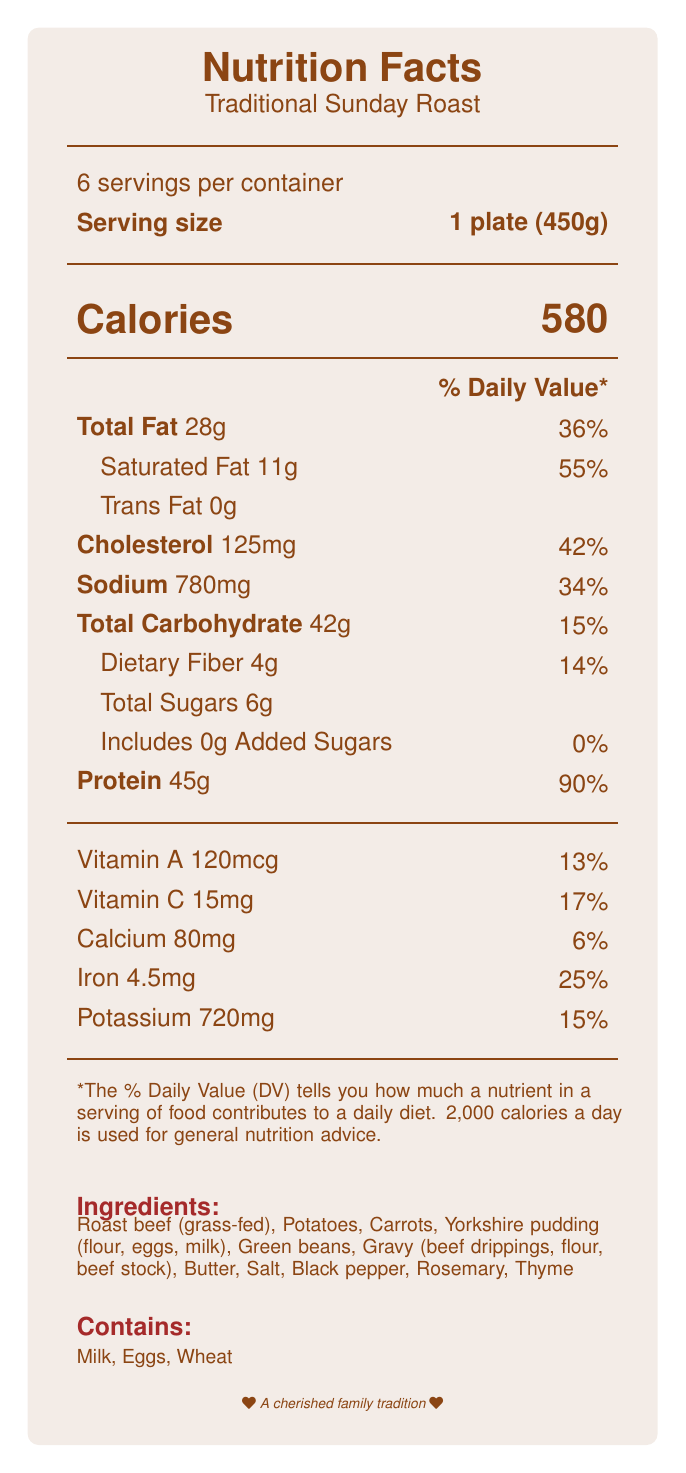What is the serving size of the Sunday roast dinner? The serving size is explicitly mentioned as "1 plate (450g)" in the document.
Answer: 1 plate (450g) How many servings are there in the entire container? The document specifies there are 6 servings per container.
Answer: 6 How many calories are in one serving of the Sunday roast dinner? The document states that one serving has 580 calories.
Answer: 580 What percentage of the Daily Value is the total fat content? The document mentions that the total fat of 28g corresponds to 36% of the Daily Value.
Answer: 36% How much protein is in one serving of the dish? The protein content per serving is listed as 45g in the document.
Answer: 45g Which ingredients contain common allergens? A. Roast beef, Potatoes, Carrots B. Milk, Eggs, Wheat C. Green beans, Butter, Thyme The document lists "Milk, Eggs, Wheat" as the allergens present.
Answer: B What is the cooking time for this traditional Sunday roast? A. 2 hours B. 3 hours C. 4 hours The cooking time is mentioned as 3 hours in the document.
Answer: B Does this meal contain any added sugars? The document states that the meal includes 0g added sugars, making the daily value 0%.
Answer: No Is the dietary fiber content high enough to meet 20% of the Daily Value? The dietary fiber content is 4g, which corresponds to 14% of the Daily Value, not 20%.
Answer: No What are the nutritional benefits listed for this meal? The document outlines these specific nutritional benefits.
Answer: High in protein for muscle health, Good source of iron for energy, Contains vegetables for essential vitamins and minerals Summarize the main ideas presented in the nutrition facts label. The summary captures the key points about nutritional values, allergens, family traditions, preparation methods, and the wholesome ingredients.
Answer: The nutrition facts label presents the nutritional content of a traditional Sunday roast dinner, including calories, fats, sugars, protein, and essential vitamins and minerals per serving size of 1 plate (450g). It also notes its containments like milk, eggs, and wheat allergens, the preparation method of slow-roasting, and its cultural significance in bringing family together. Ingredients used are locally sourced and include roast beef, potatoes, carrots, and other elements that underline the dish's wholesome and traditional values. How much calcium is provided per serving? The document lists the calcium content as 80mg per serving.
Answer: 80mg What is the percentage of Daily Value for Iron? The iron content per serving is listed as 25% of the Daily Value.
Answer: 25% Can you determine the exact origin of the roast beef? The document only mentions "Roast beef (grass-fed)" without specifying the exact origin.
Answer: Cannot be determined 